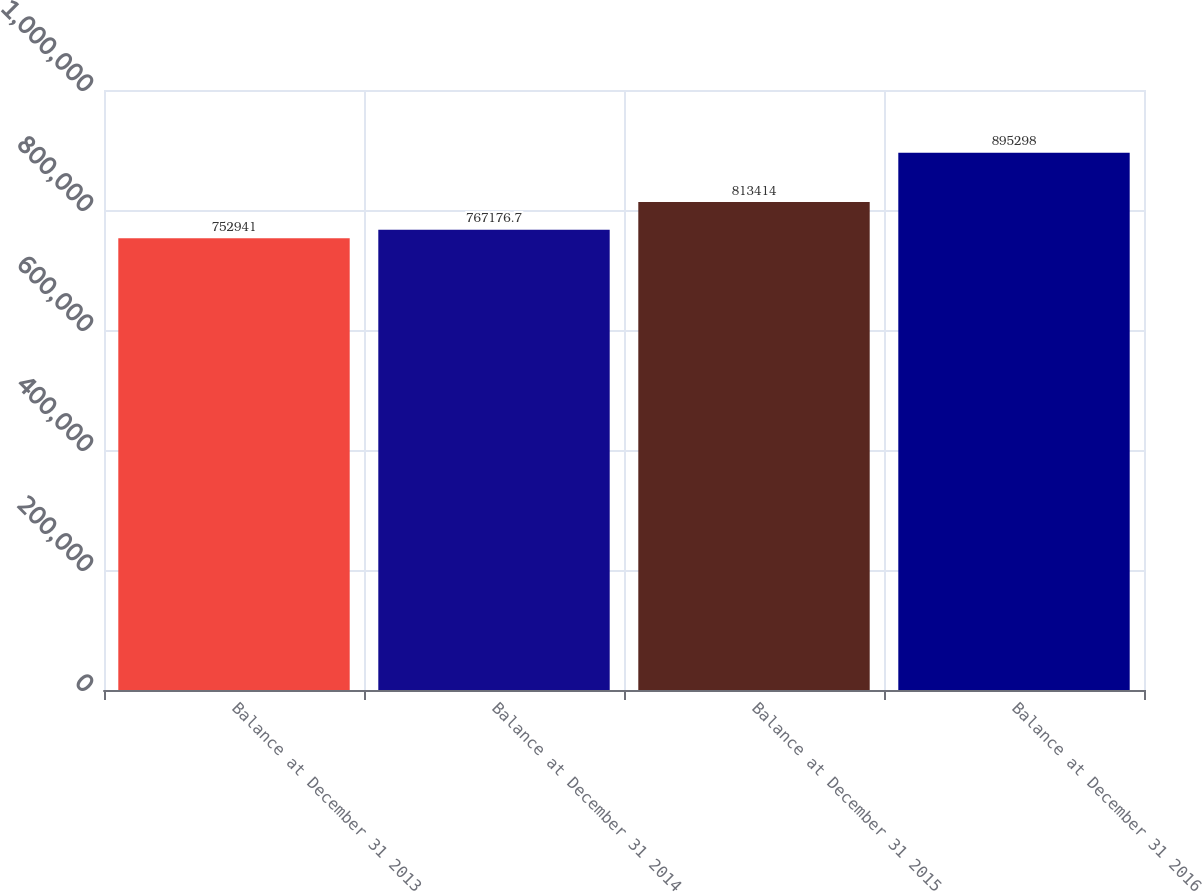Convert chart to OTSL. <chart><loc_0><loc_0><loc_500><loc_500><bar_chart><fcel>Balance at December 31 2013<fcel>Balance at December 31 2014<fcel>Balance at December 31 2015<fcel>Balance at December 31 2016<nl><fcel>752941<fcel>767177<fcel>813414<fcel>895298<nl></chart> 